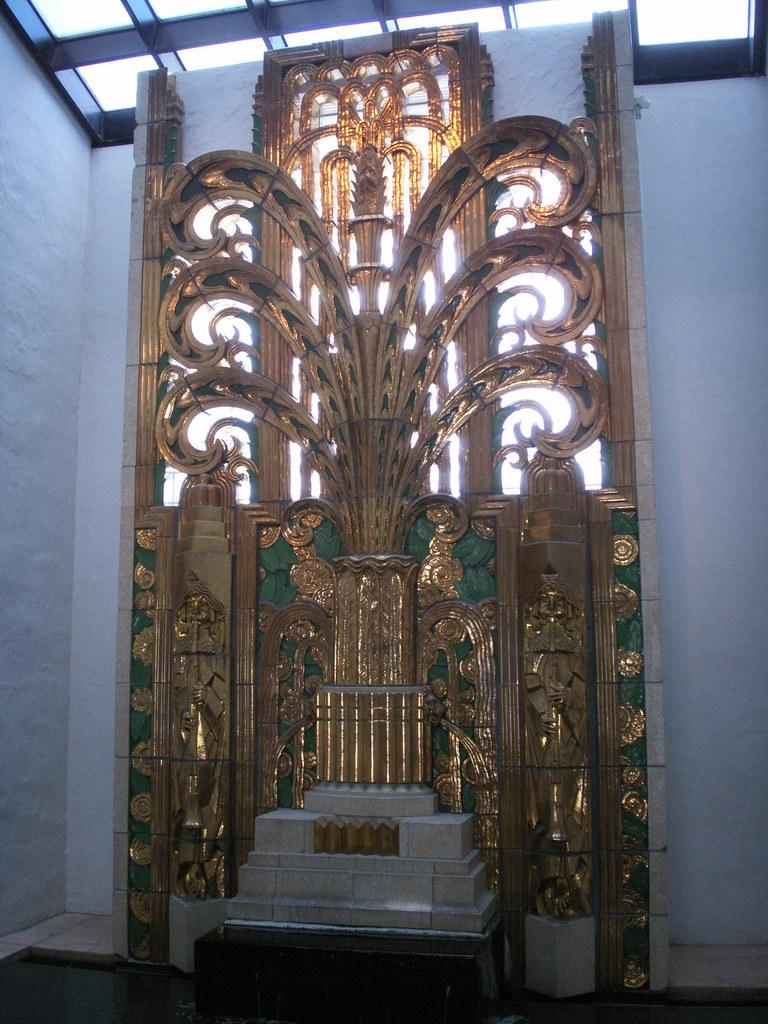What color are the walls in the image? The walls in the image are white. What can be seen on the walls in the image? There is a decoration on the walls in the image. What colors are used in the decoration? The decoration is gold and green in color. What hobbies are the people in the image engaged in? There are no people visible in the image, so their hobbies cannot be determined. 